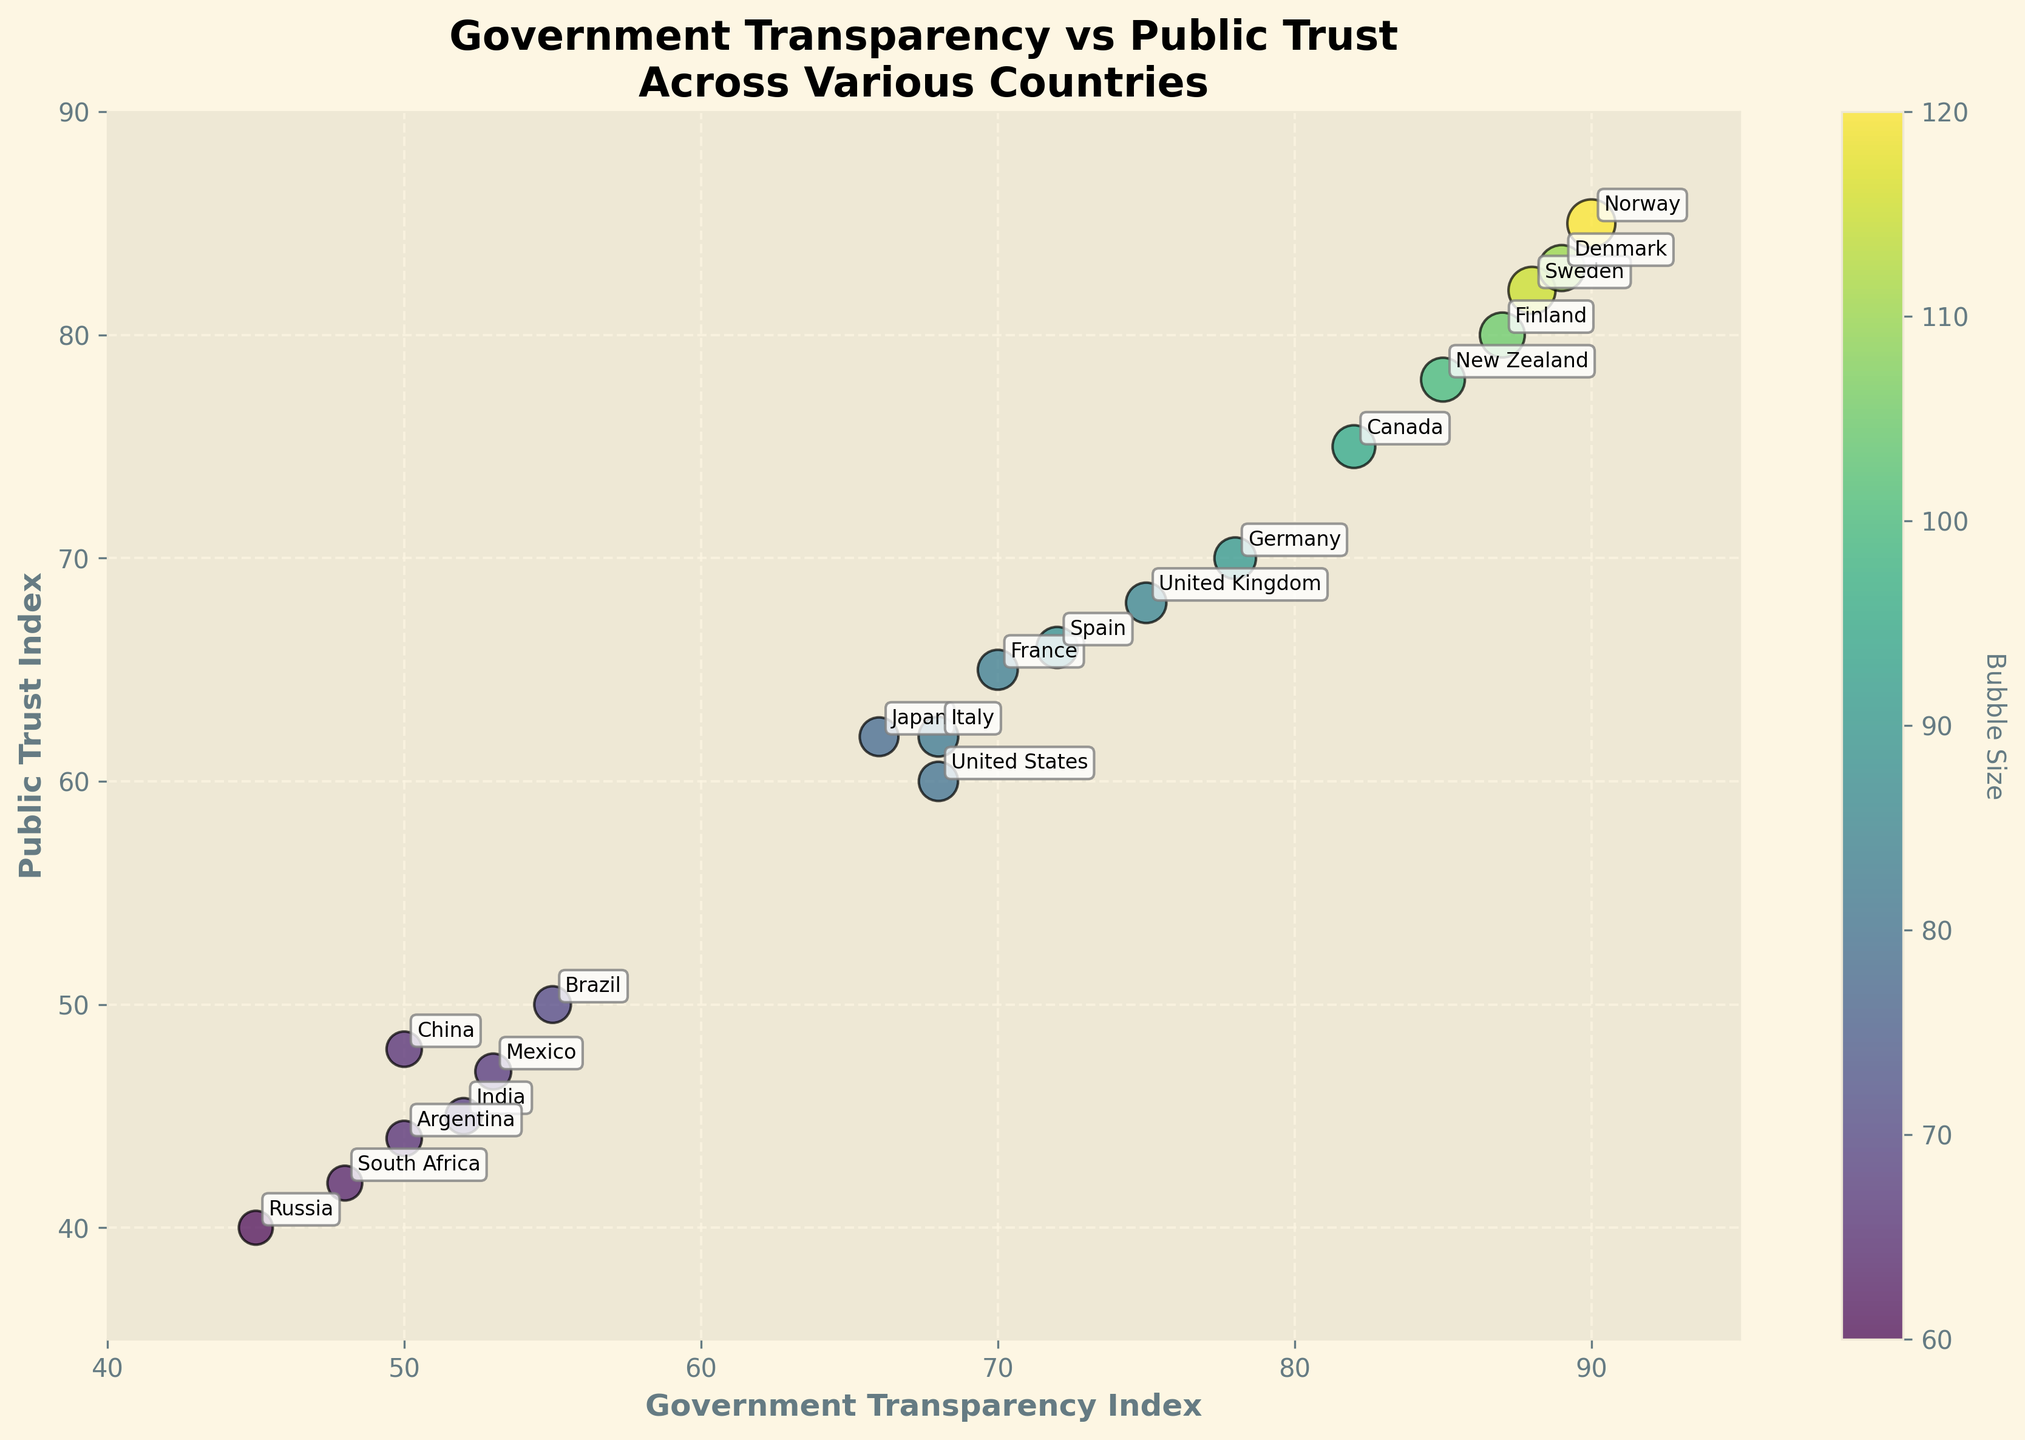What's the title of the chart? The title of the chart can be found at the top of the figure. It provides a summary of the data being presented and contains key terms like "Government Transparency" and "Public Trust."
Answer: Government Transparency vs Public Trust Across Various Countries What does the x-axis represent? The x-axis label can be found below the horizontal axis. It describes the data plotted along the x-axis, focusing on a specific metric.
Answer: Government Transparency Index How is the size of the bubbles determined? The bubble size in a bubble chart typically represents an additional variable. By examining the color bar and the dataset, we can deduce that the size is determined by the 'BubbleSize' column.
Answer: Bubble Size Which country has the highest Public Trust Index? To find the country with the highest Public Trust Index, locate the highest value on the y-axis and identify which country's bubble corresponds to this position.
Answer: Norway How many countries have a Government Transparency Index greater than 80? Check the data points on the x-axis that have values greater than 80 and count the number of bubbles beyond this threshold.
Answer: 6 Which countries have both a Government Transparency Index and Public Trust Index above 80? Identify bubbles that are located above the 80 mark on both x and y axes and verify their annotations.
Answer: Norway, Sweden, Denmark, Finland Are there any countries with a Government Transparency Index below 60 but a Public Trust Index above 60? Look for bubbles to the left of 60 on the x-axis and check if any of those also appear above 60 on the y-axis.
Answer: No How does Germany compare to Canada in terms of Government Transparency Index? Locate the positions of Germany and Canada on the x-axis and compare which is further to the right.
Answer: Germany has a lower Government Transparency Index than Canada Which country has the smallest bubble size? Examine the bubbles in the chart and identify the smallest one by visual comparison and referencing the 'BubbleSize' data.
Answer: Russia Does Brazil have a higher Public Trust Index than India? Compare the vertical positions of the bubbles marked 'Brazil' and 'India' to determine which is higher on the y-axis.
Answer: Yes 